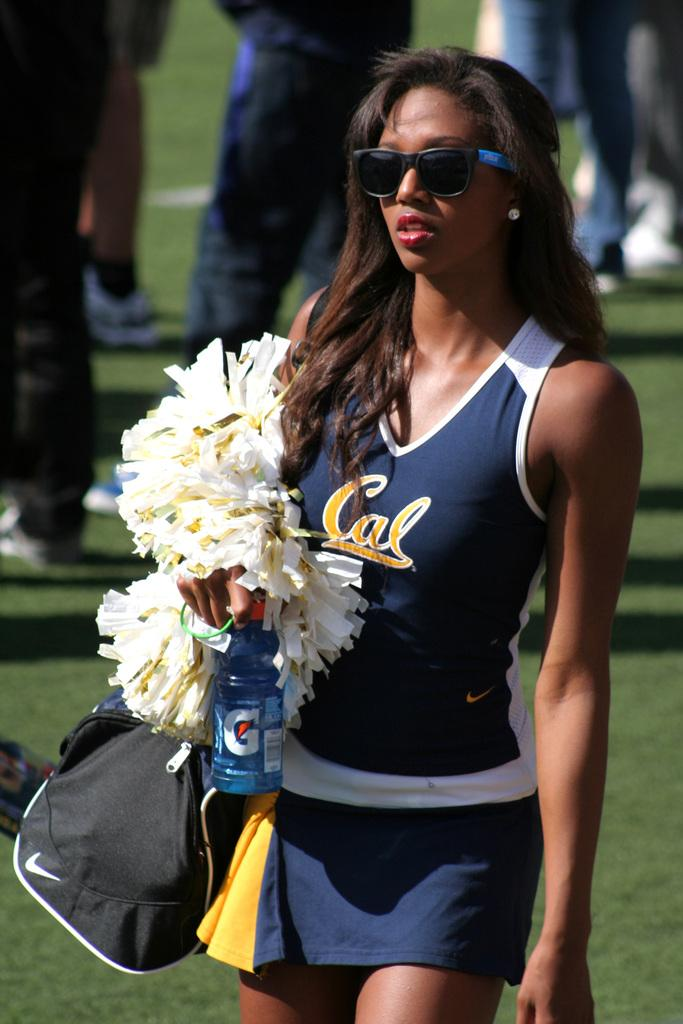<image>
Offer a succinct explanation of the picture presented. A cheerleader from Cal is holding a gatorade bottle 